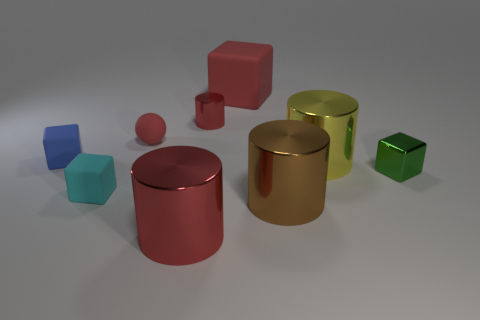There is a red shiny object in front of the small metal cube; is its shape the same as the large yellow object behind the cyan block?
Make the answer very short. Yes. Are there the same number of tiny blue matte cubes that are to the right of the small blue block and small purple shiny objects?
Provide a short and direct response. Yes. What is the material of the blue thing that is the same shape as the cyan object?
Your answer should be compact. Rubber. What shape is the red metallic object in front of the thing that is on the right side of the yellow cylinder?
Your response must be concise. Cylinder. Do the large red thing in front of the green block and the tiny red cylinder have the same material?
Provide a short and direct response. Yes. Is the number of green cubes to the right of the small green metal object the same as the number of large shiny objects behind the cyan cube?
Keep it short and to the point. No. There is another cylinder that is the same color as the tiny shiny cylinder; what is it made of?
Make the answer very short. Metal. There is a small block that is on the left side of the cyan cube; what number of large red blocks are behind it?
Offer a very short reply. 1. There is a matte cube to the right of the large red cylinder; is its color the same as the big metal cylinder in front of the big brown thing?
Provide a succinct answer. Yes. What is the material of the red cube that is the same size as the brown shiny cylinder?
Give a very brief answer. Rubber. 